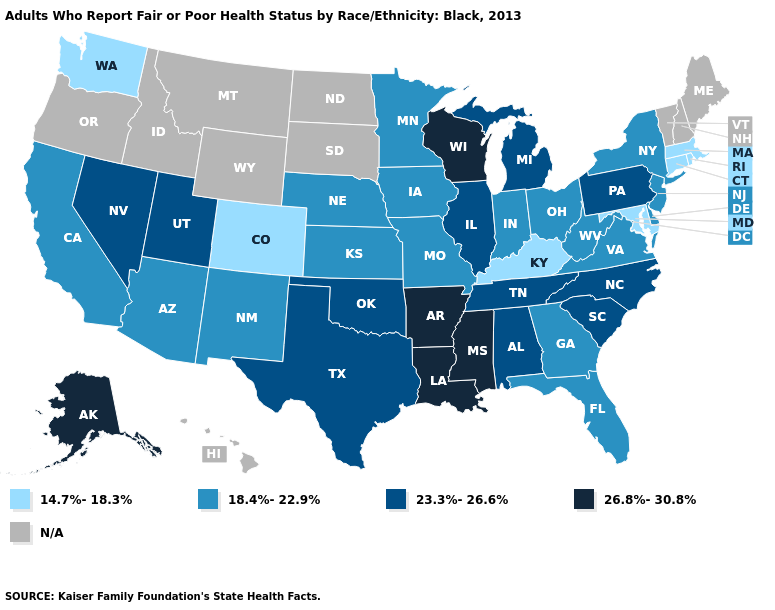What is the value of Illinois?
Concise answer only. 23.3%-26.6%. Among the states that border Arizona , which have the lowest value?
Write a very short answer. Colorado. Does the map have missing data?
Answer briefly. Yes. What is the value of South Dakota?
Short answer required. N/A. Name the states that have a value in the range 14.7%-18.3%?
Give a very brief answer. Colorado, Connecticut, Kentucky, Maryland, Massachusetts, Rhode Island, Washington. What is the value of Pennsylvania?
Keep it brief. 23.3%-26.6%. Name the states that have a value in the range 18.4%-22.9%?
Keep it brief. Arizona, California, Delaware, Florida, Georgia, Indiana, Iowa, Kansas, Minnesota, Missouri, Nebraska, New Jersey, New Mexico, New York, Ohio, Virginia, West Virginia. Which states hav the highest value in the Northeast?
Answer briefly. Pennsylvania. Name the states that have a value in the range 14.7%-18.3%?
Quick response, please. Colorado, Connecticut, Kentucky, Maryland, Massachusetts, Rhode Island, Washington. Does the first symbol in the legend represent the smallest category?
Be succinct. Yes. Name the states that have a value in the range 26.8%-30.8%?
Quick response, please. Alaska, Arkansas, Louisiana, Mississippi, Wisconsin. Name the states that have a value in the range N/A?
Keep it brief. Hawaii, Idaho, Maine, Montana, New Hampshire, North Dakota, Oregon, South Dakota, Vermont, Wyoming. 